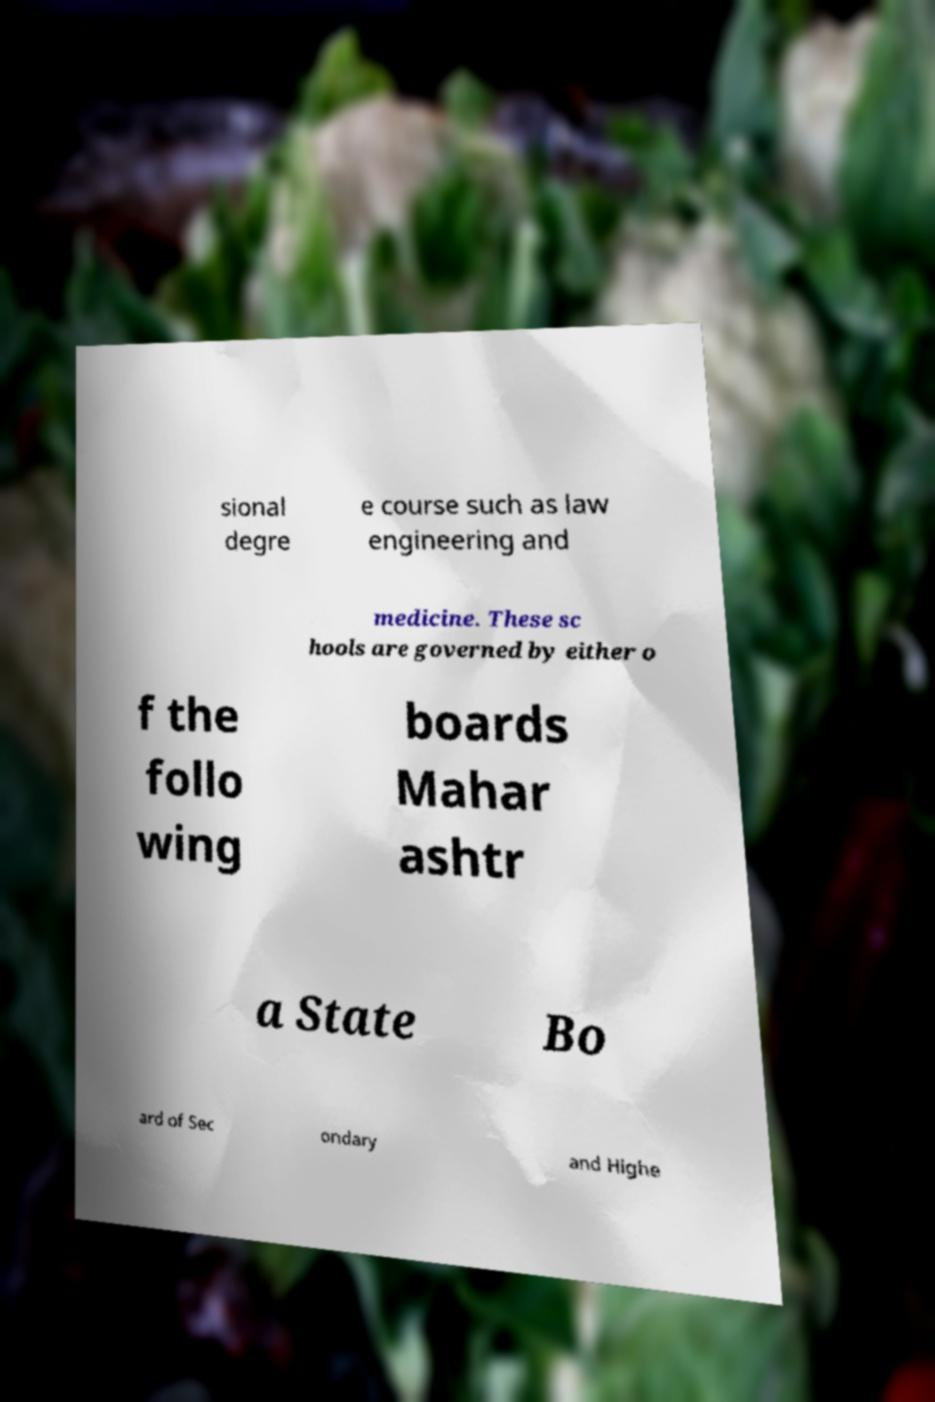There's text embedded in this image that I need extracted. Can you transcribe it verbatim? sional degre e course such as law engineering and medicine. These sc hools are governed by either o f the follo wing boards Mahar ashtr a State Bo ard of Sec ondary and Highe 